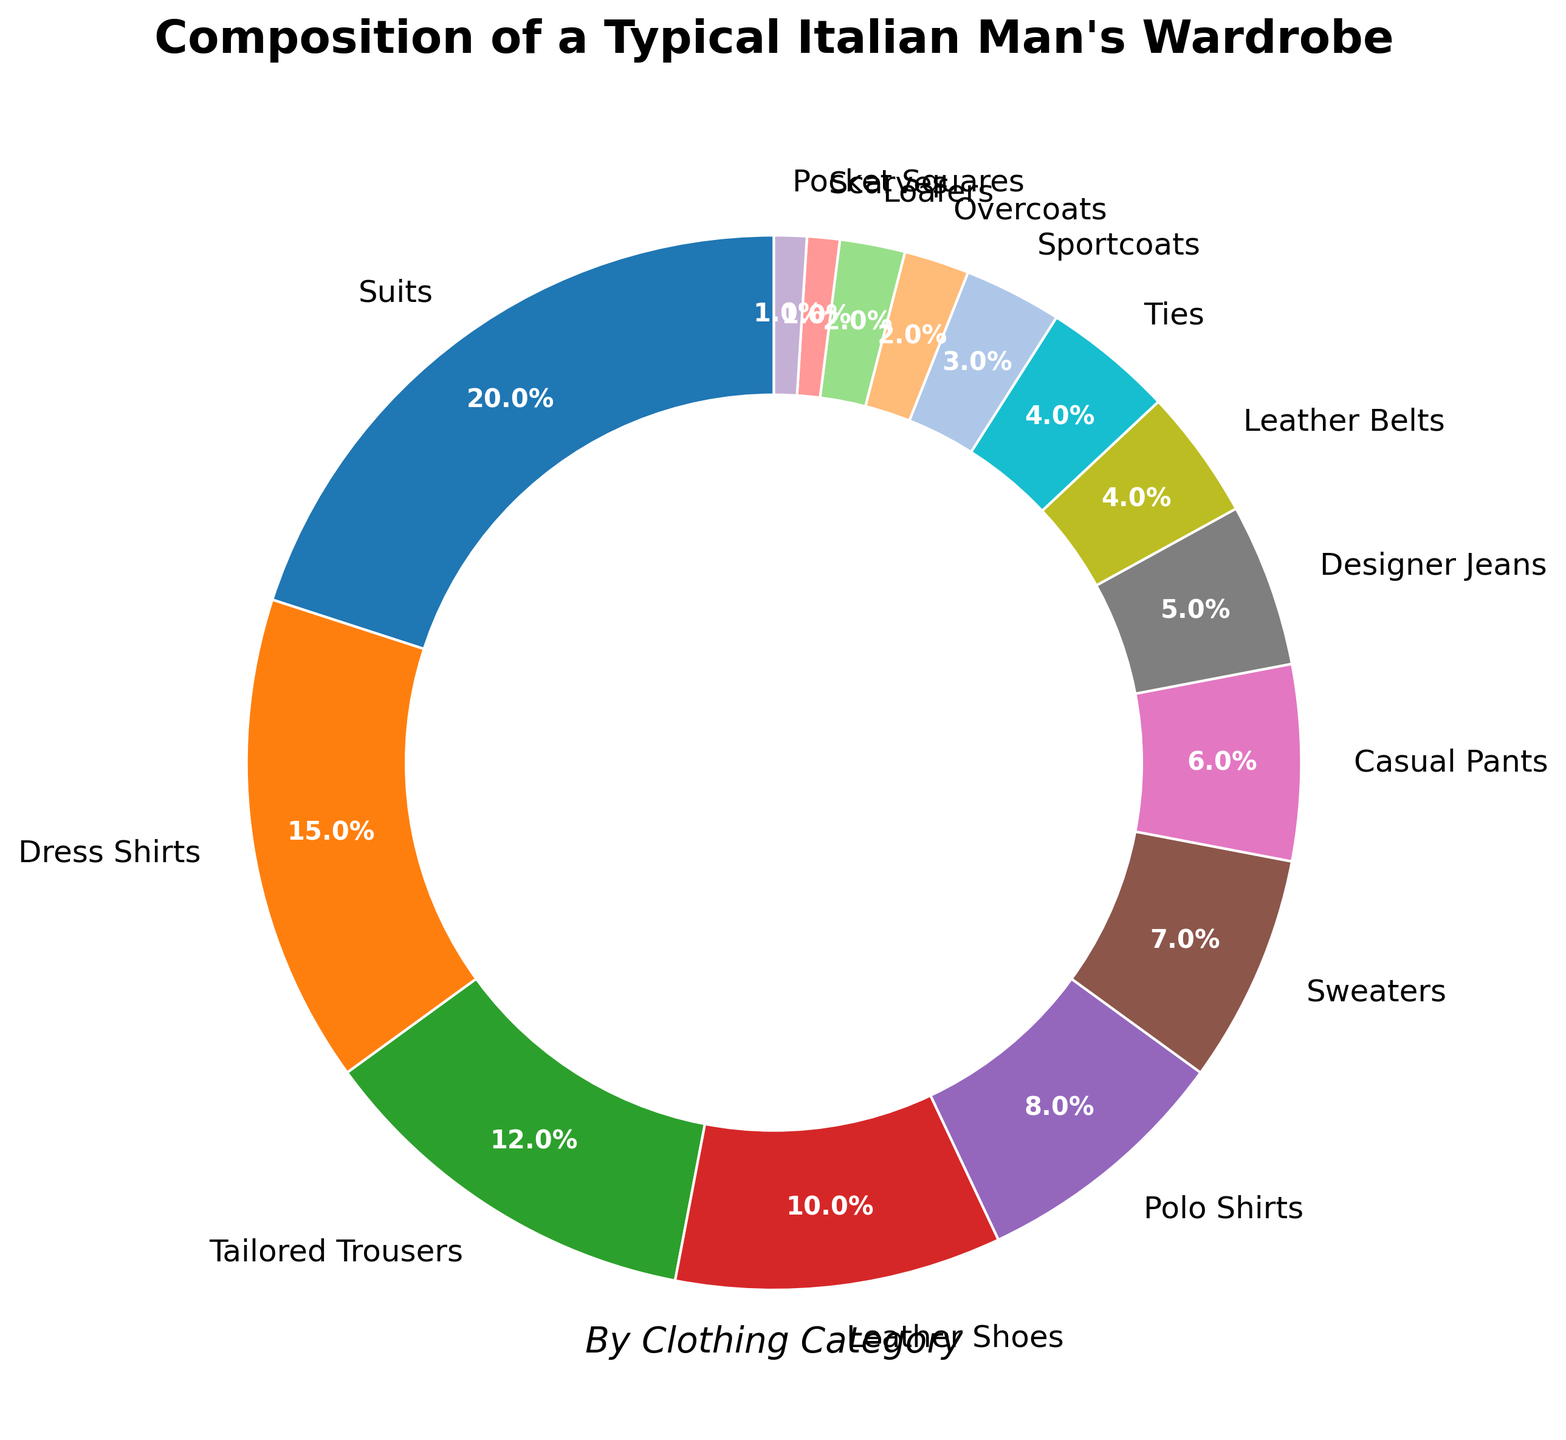What is the percentage of Suits combined with Dress Shirts in the wardrobe? The percentage of Suits is 20% and the percentage of Dress Shirts is 15%. Adding these two numbers together, 20% + 15% = 35%.
Answer: 35% Which clothing category has the smallest percentage, and what is it? The smallest percentage in the wardrobe composition is 1%, which belongs to both Scarves and Pocket Squares.
Answer: Scarves and Pocket Squares at 1% Are there more Leather Shoes or Tailored Trousers in the wardrobe? Leather Shoes have a percentage of 10%, while Tailored Trousers have 12%. Since 12% (Tailored Trousers) is greater than 10% (Leather Shoes), there are more Tailored Trousers.
Answer: Tailored Trousers What is the combined percentage of Leather Shoes and Loafers? The percentage for Leather Shoes is 10% and for Loafers is 2%. Adding these two percentages gives us 10% + 2% = 12%.
Answer: 12% Which is greater, the sum of Dress Shirts and Polo Shirts or the sum of Sweaters and Casual Pants? Dress Shirts account for 15%, and Polo Shirts account for 8%, resulting in a sum of 15% + 8% = 23%. Sweaters, on the other hand, account for 7%, and Casual Pants account for 6%, leading to a sum of 7% + 6% = 13%. Comparing 23% and 13%, the sum of Dress Shirts and Polo Shirts is greater.
Answer: Dress Shirts and Polo Shirts What is the percentage difference between Designer Jeans and Suits? Suits have a percentage of 20% and Designer Jeans have 5%. The percentage difference is calculated as 20% - 5% = 15%.
Answer: 15% If we group leather items (Leather Shoes, Leather Belts, and Loafers), what is their combined percentage? Leather Shoes account for 10%, Leather Belts account for 4%, and Loafers for 2%. Adding these percentages, 10% + 4% + 2% = 16%.
Answer: 16% Between Sweaters and Polo Shirts, which category has a smaller percentage, and by how much? Sweaters have a percentage of 7%, while Polo Shirts have 8%. The difference is 8% - 7% = 1%. Sweaters have a smaller percentage by 1%.
Answer: Sweaters by 1% What is the average percentage of Sportcoats, Overcoats, and Scarves? The percentages are Sportcoats 3%, Overcoats 2%, and Scarves 1%. Adding these together gives 3% + 2% + 1% = 6%. To find the average, divide by 3: 6% ÷ 3 = 2%.
Answer: 2% Which visual attribute corresponds to the Overcoats category, such as the color or position in the pie chart? The Overcoats category is visually represented in light purple color and is positioned between the Sportcoats and Loafers sections. This can be identified visually from the color and relative position in the pie chart.
Answer: Light purple color 